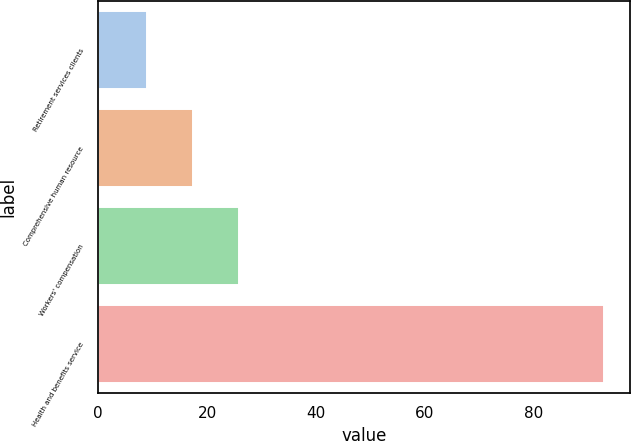Convert chart. <chart><loc_0><loc_0><loc_500><loc_500><bar_chart><fcel>Retirement services clients<fcel>Comprehensive human resource<fcel>Workers' compensation<fcel>Health and benefits service<nl><fcel>9<fcel>17.4<fcel>25.8<fcel>93<nl></chart> 